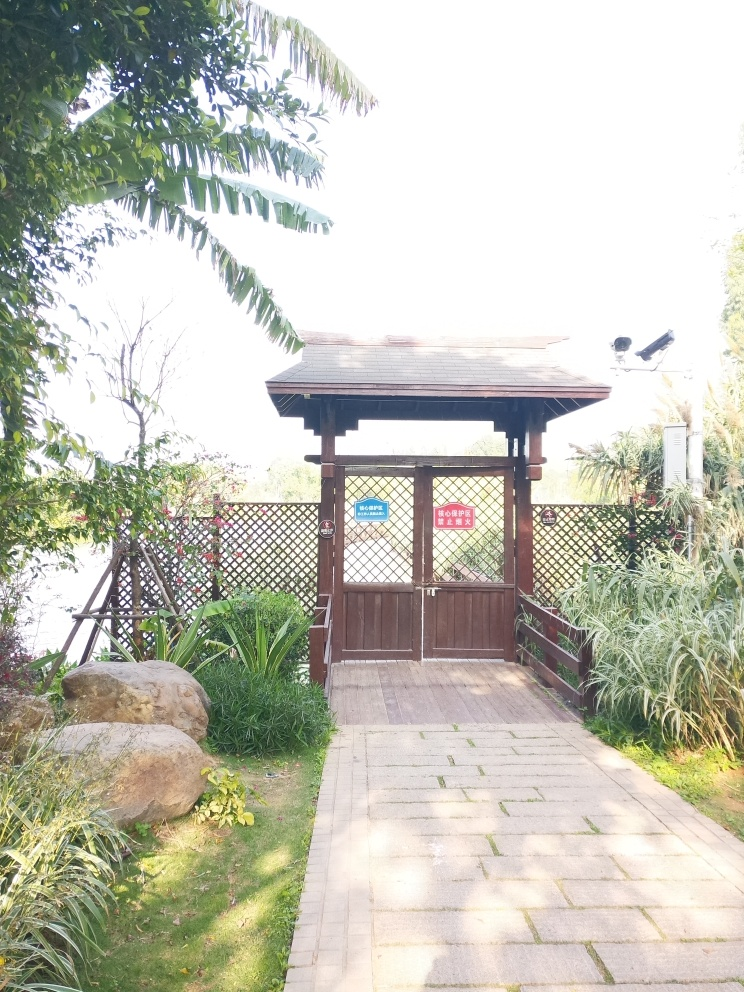Can you describe the setting and atmosphere conveyed by this image? The image captures a quiet garden corner with a wooden pavilion, possibly within a park or a private garden. It's surrounded by lush plants and a neatly paved path, creating a tranquil and inviting atmosphere. The garden appears well-kept, with signs suggesting designated areas, possibly for relaxation or specific activities, contributing to the sense of order and peace. 